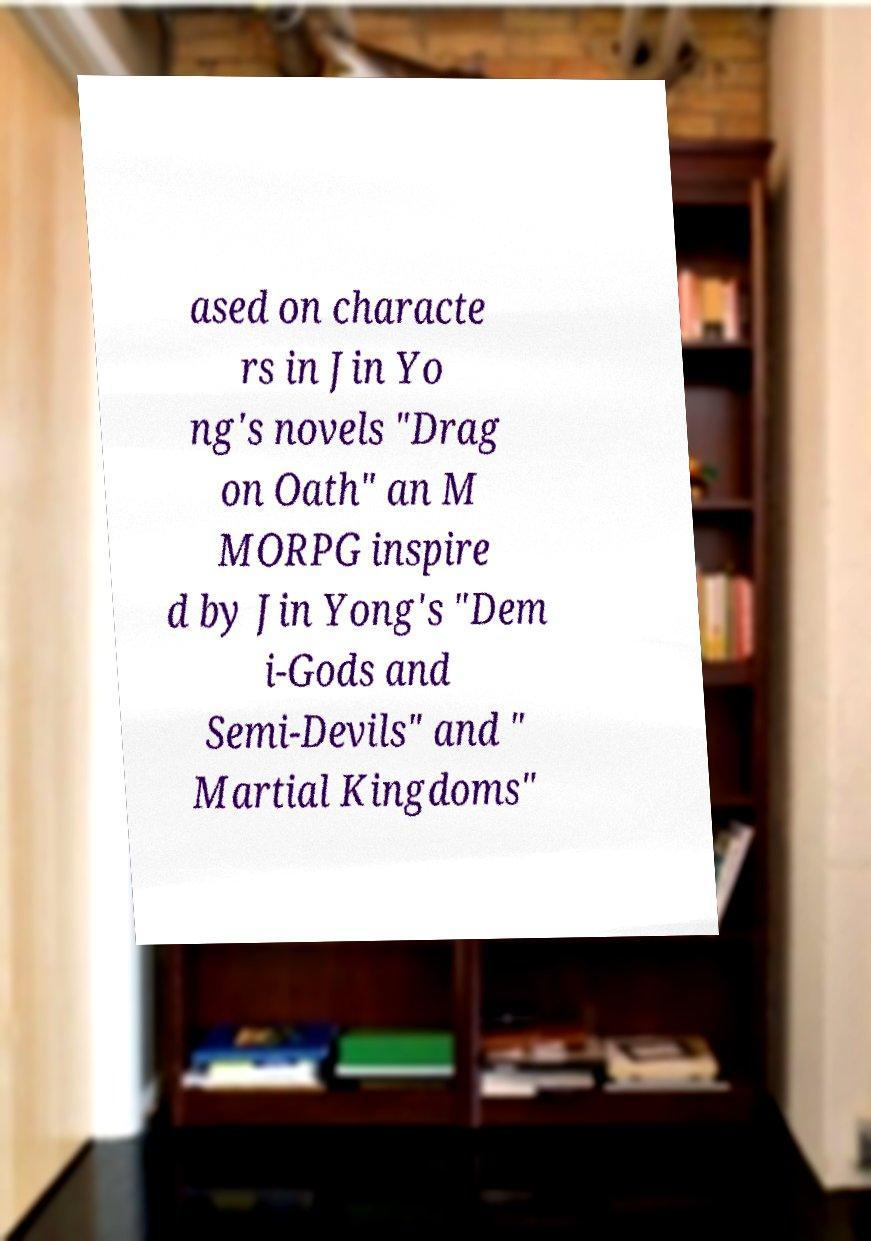There's text embedded in this image that I need extracted. Can you transcribe it verbatim? ased on characte rs in Jin Yo ng's novels "Drag on Oath" an M MORPG inspire d by Jin Yong's "Dem i-Gods and Semi-Devils" and " Martial Kingdoms" 